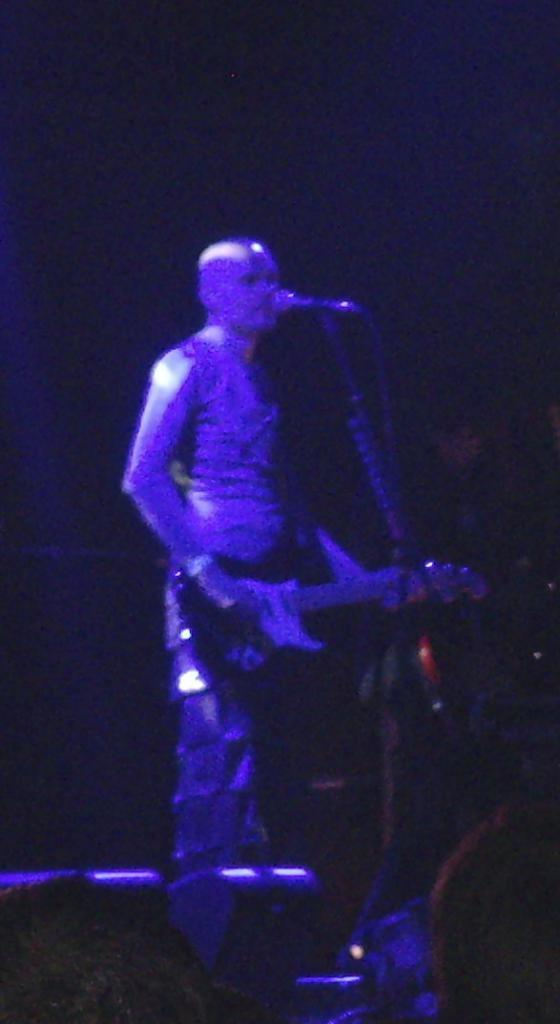Who is the main subject in the image? There is a person in the image. Where is the person located? The person is standing on a stage. What is the person doing on the stage? The person is playing a guitar. What is the purpose of the microphone in front of the person? The microphone is likely used for amplifying the person's voice while performing. What type of polish is the person wearing on their nails in the image? There is no indication of nail polish or any focus on the person's nails in the image. What color is the skirt the person is wearing in the image? The person in the image is not wearing a skirt; they are wearing pants or trousers. 